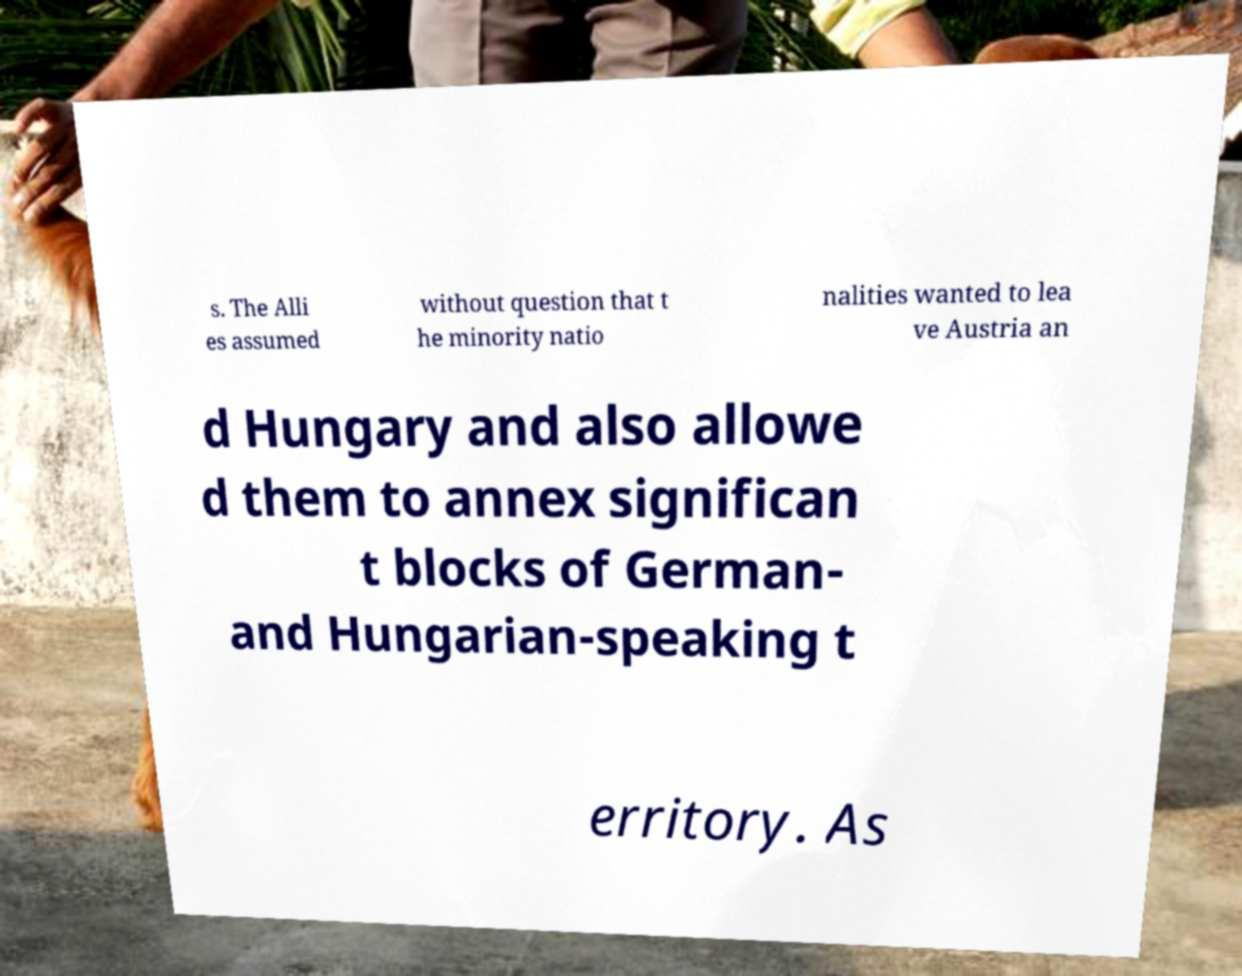Please identify and transcribe the text found in this image. s. The Alli es assumed without question that t he minority natio nalities wanted to lea ve Austria an d Hungary and also allowe d them to annex significan t blocks of German- and Hungarian-speaking t erritory. As 